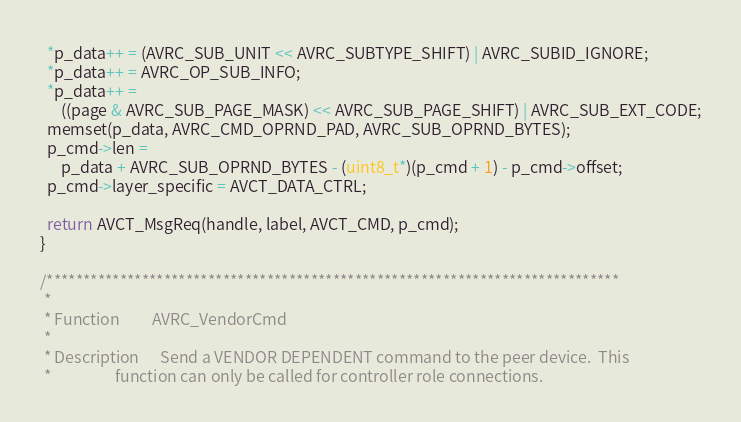Convert code to text. <code><loc_0><loc_0><loc_500><loc_500><_C++_>  *p_data++ = (AVRC_SUB_UNIT << AVRC_SUBTYPE_SHIFT) | AVRC_SUBID_IGNORE;
  *p_data++ = AVRC_OP_SUB_INFO;
  *p_data++ =
      ((page & AVRC_SUB_PAGE_MASK) << AVRC_SUB_PAGE_SHIFT) | AVRC_SUB_EXT_CODE;
  memset(p_data, AVRC_CMD_OPRND_PAD, AVRC_SUB_OPRND_BYTES);
  p_cmd->len =
      p_data + AVRC_SUB_OPRND_BYTES - (uint8_t*)(p_cmd + 1) - p_cmd->offset;
  p_cmd->layer_specific = AVCT_DATA_CTRL;

  return AVCT_MsgReq(handle, label, AVCT_CMD, p_cmd);
}

/******************************************************************************
 *
 * Function         AVRC_VendorCmd
 *
 * Description      Send a VENDOR DEPENDENT command to the peer device.  This
 *                  function can only be called for controller role connections.</code> 